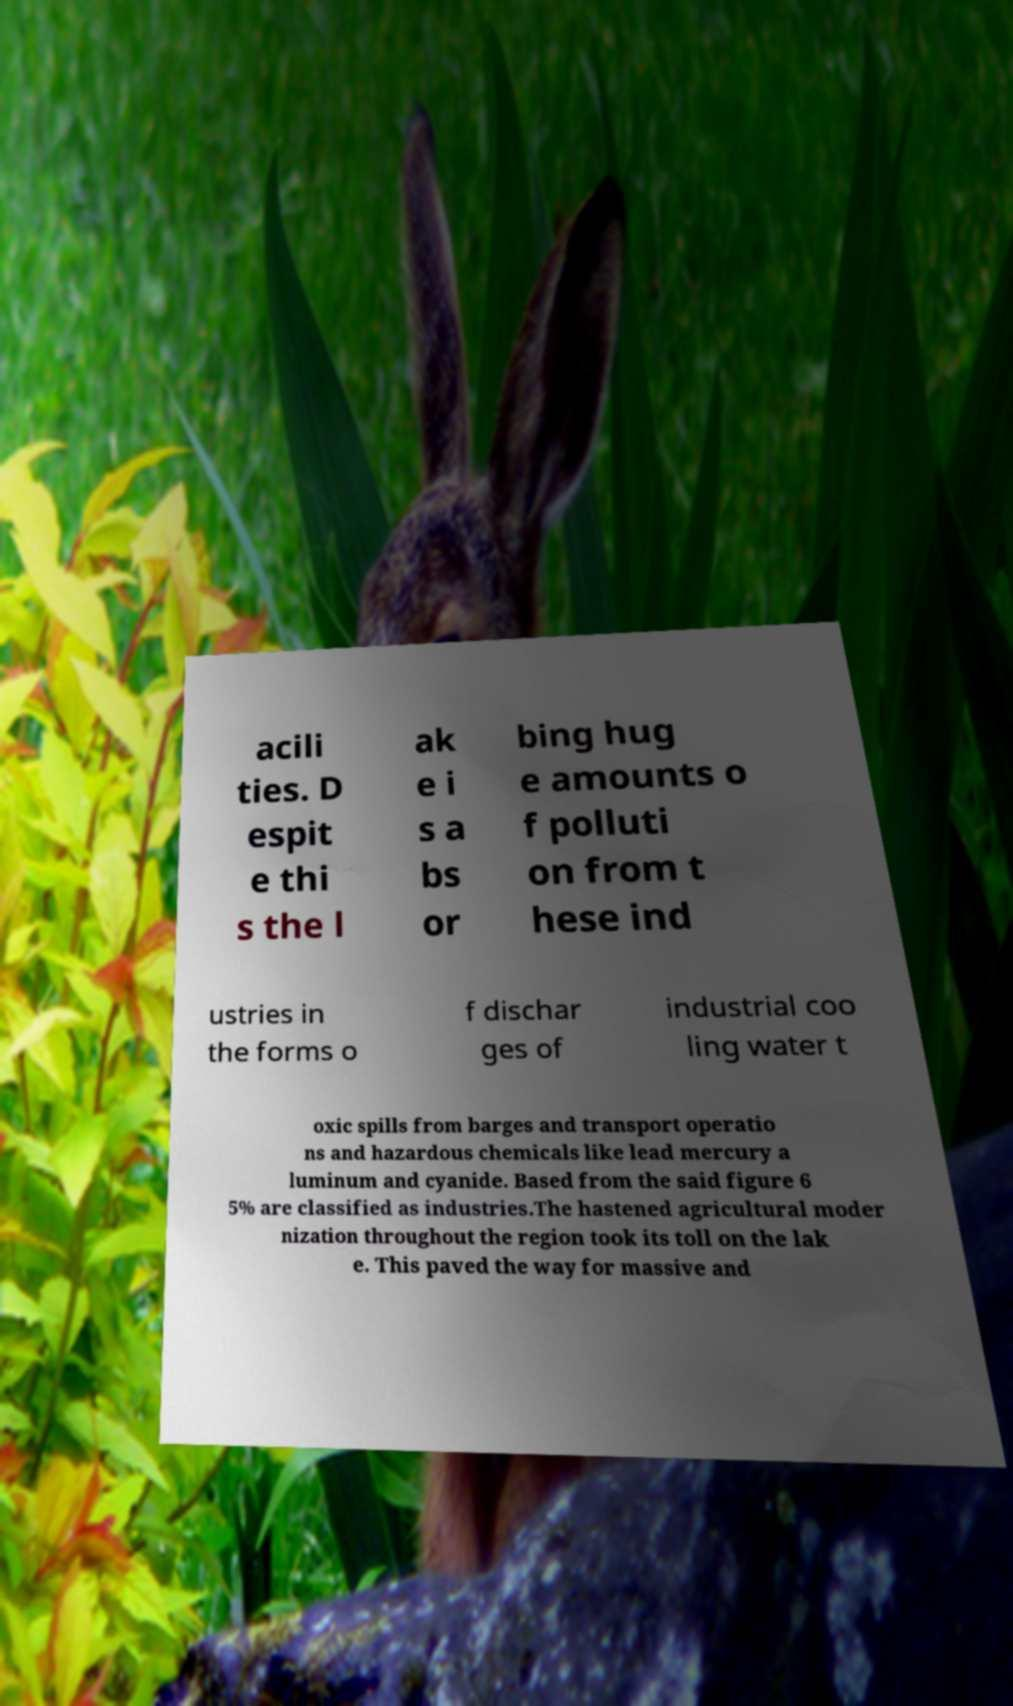Please identify and transcribe the text found in this image. acili ties. D espit e thi s the l ak e i s a bs or bing hug e amounts o f polluti on from t hese ind ustries in the forms o f dischar ges of industrial coo ling water t oxic spills from barges and transport operatio ns and hazardous chemicals like lead mercury a luminum and cyanide. Based from the said figure 6 5% are classified as industries.The hastened agricultural moder nization throughout the region took its toll on the lak e. This paved the way for massive and 